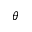Convert formula to latex. <formula><loc_0><loc_0><loc_500><loc_500>^ { \theta }</formula> 